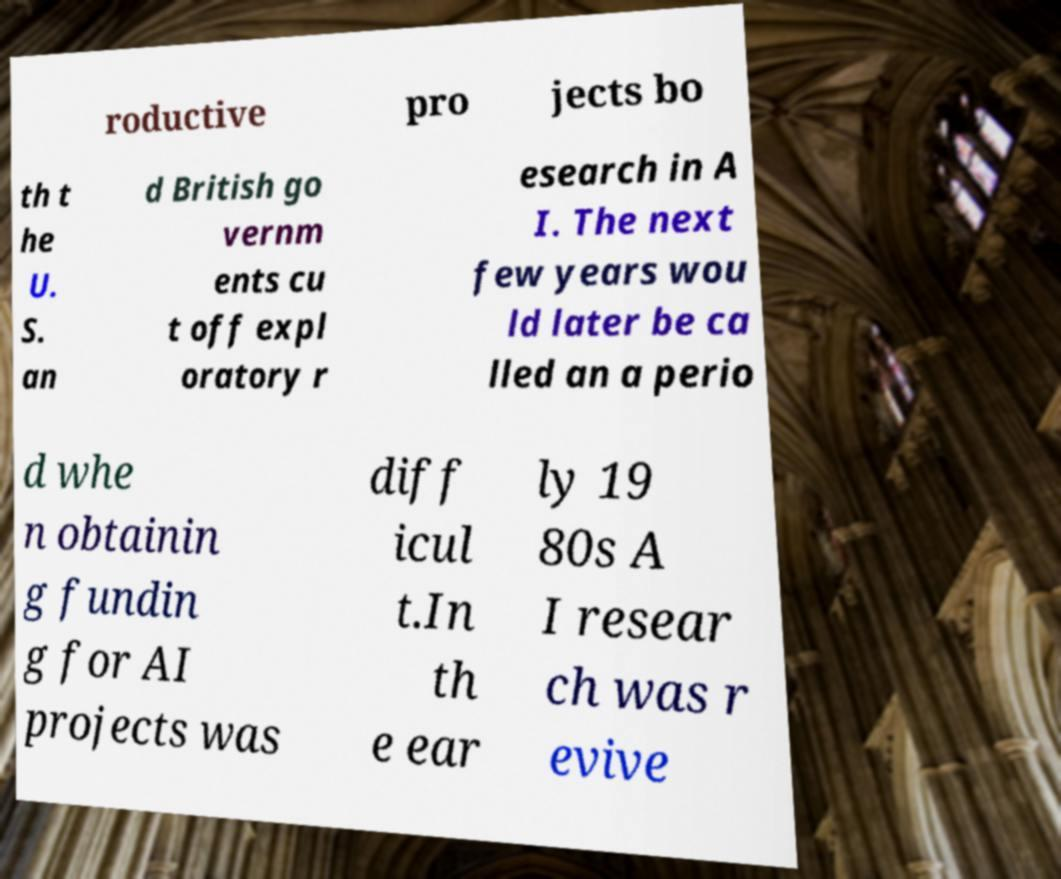I need the written content from this picture converted into text. Can you do that? roductive pro jects bo th t he U. S. an d British go vernm ents cu t off expl oratory r esearch in A I. The next few years wou ld later be ca lled an a perio d whe n obtainin g fundin g for AI projects was diff icul t.In th e ear ly 19 80s A I resear ch was r evive 